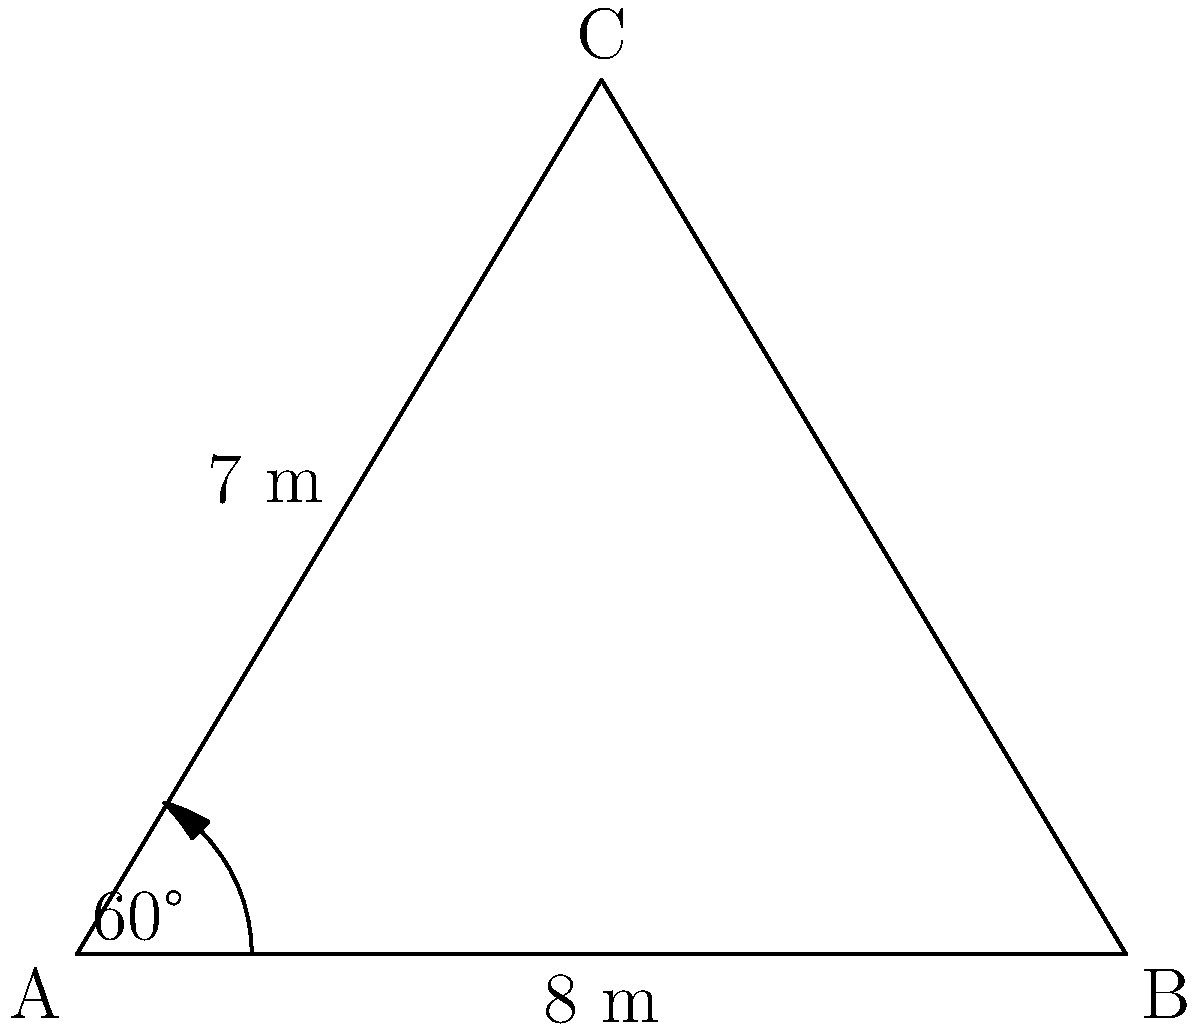The triangular town square of Tintinara is represented by triangle ABC in the diagram. If the length of side AB is 8 meters, AC is 7 meters, and the angle between these sides is 60°, what is the area of the town square in square meters? To find the area of the triangular town square, we can use the formula for the area of a triangle given two sides and the included angle:

$$A = \frac{1}{2} \cdot a \cdot b \cdot \sin(C)$$

Where:
$A$ is the area of the triangle
$a$ and $b$ are the lengths of the two known sides
$C$ is the angle between these sides

Given:
$a = 8$ meters (side AB)
$b = 7$ meters (side AC)
$C = 60°$

Step 1: Substitute the values into the formula:
$$A = \frac{1}{2} \cdot 8 \cdot 7 \cdot \sin(60°)$$

Step 2: Calculate $\sin(60°)$:
$\sin(60°) = \frac{\sqrt{3}}{2}$

Step 3: Substitute this value and simplify:
$$A = \frac{1}{2} \cdot 8 \cdot 7 \cdot \frac{\sqrt{3}}{2}$$
$$A = 14 \cdot \frac{\sqrt{3}}{2}$$
$$A = 7\sqrt{3}$$

Step 4: Calculate the final value (rounded to two decimal places):
$$A \approx 12.12 \text{ square meters}$$

Therefore, the area of Tintinara's triangular town square is approximately 12.12 square meters.
Answer: $12.12 \text{ m}^2$ 